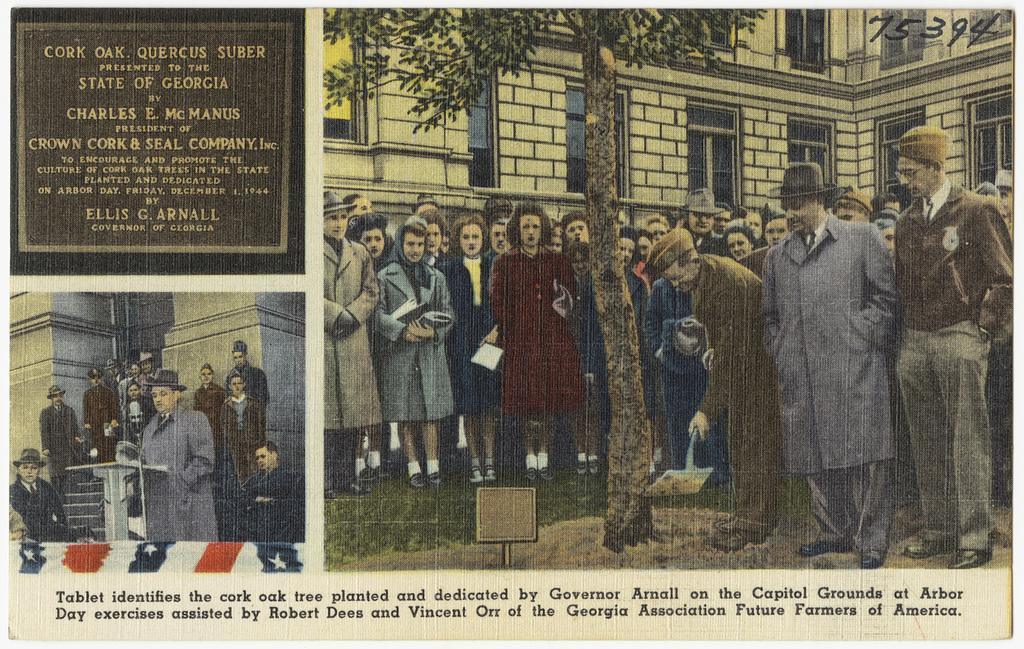Can you describe this image briefly? This is a picture of a paper, where there are photos of group of people standing , there are buildings, a tree , podium, a flag , and a board , and there are words and numbers on the paper. 